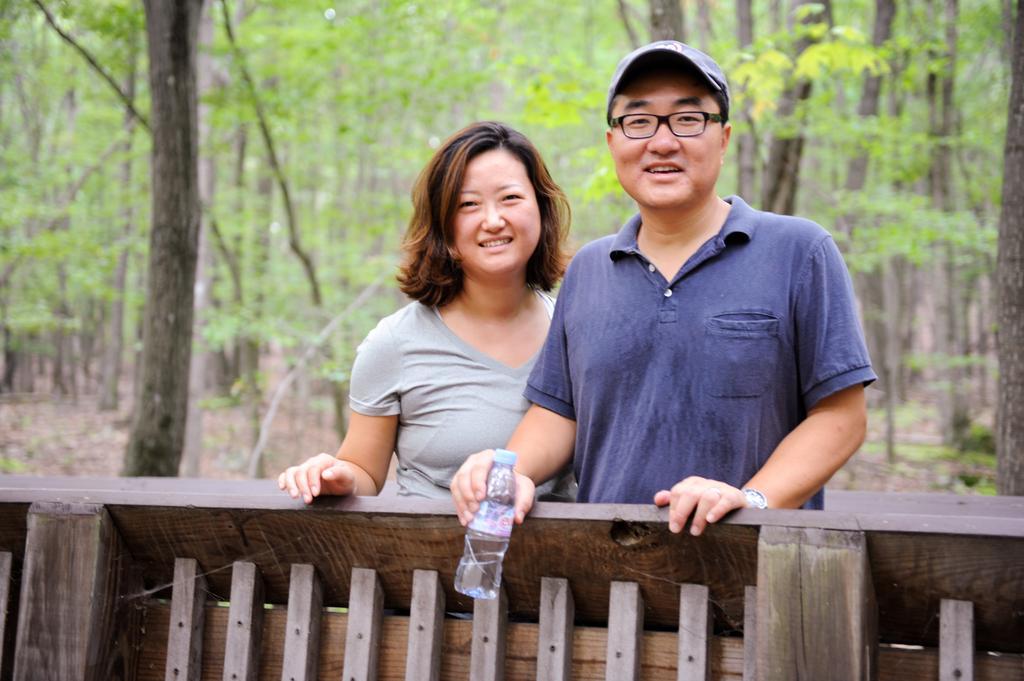Please provide a concise description of this image. In this image there is a wooden railing, behind the wooden railing there is a man and a woman standing and a man is holding a bottle in his hand, in the background there are trees and it is blurred. 